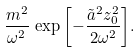<formula> <loc_0><loc_0><loc_500><loc_500>\frac { m ^ { 2 } } { \omega ^ { 2 } } \, \exp { \left [ - \frac { \tilde { a } ^ { 2 } z _ { 0 } ^ { 2 } } { 2 \omega ^ { 2 } } \right ] } .</formula> 